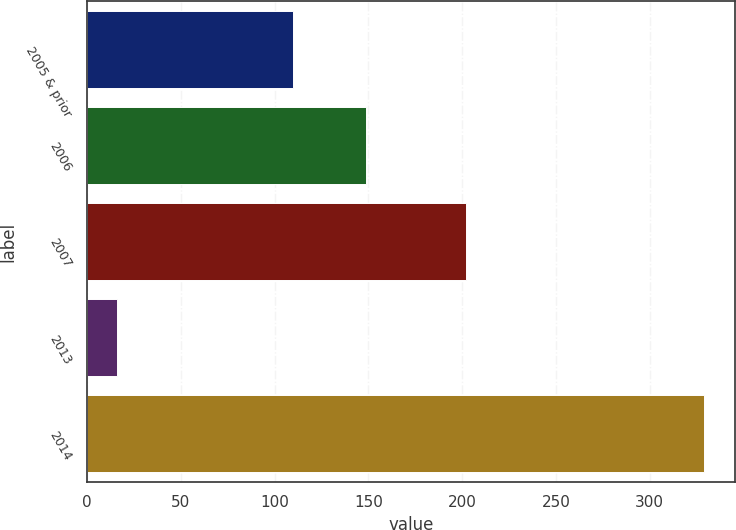<chart> <loc_0><loc_0><loc_500><loc_500><bar_chart><fcel>2005 & prior<fcel>2006<fcel>2007<fcel>2013<fcel>2014<nl><fcel>110<fcel>149<fcel>202<fcel>16<fcel>329<nl></chart> 